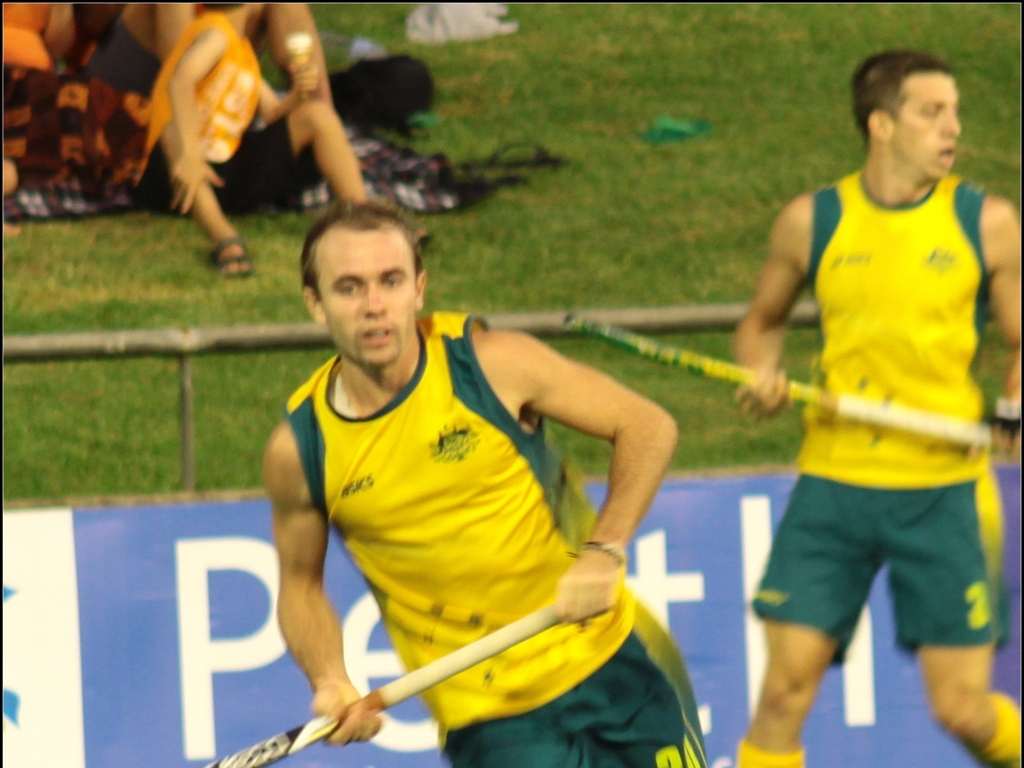What sport is being played in this image? The person in the image appears to be wearing a uniform that is typical for field hockey players, complete with a jersey, shorts, and carrying a hockey stick. Considering the attire and equipment, it is likely that the sport being played is field hockey. 